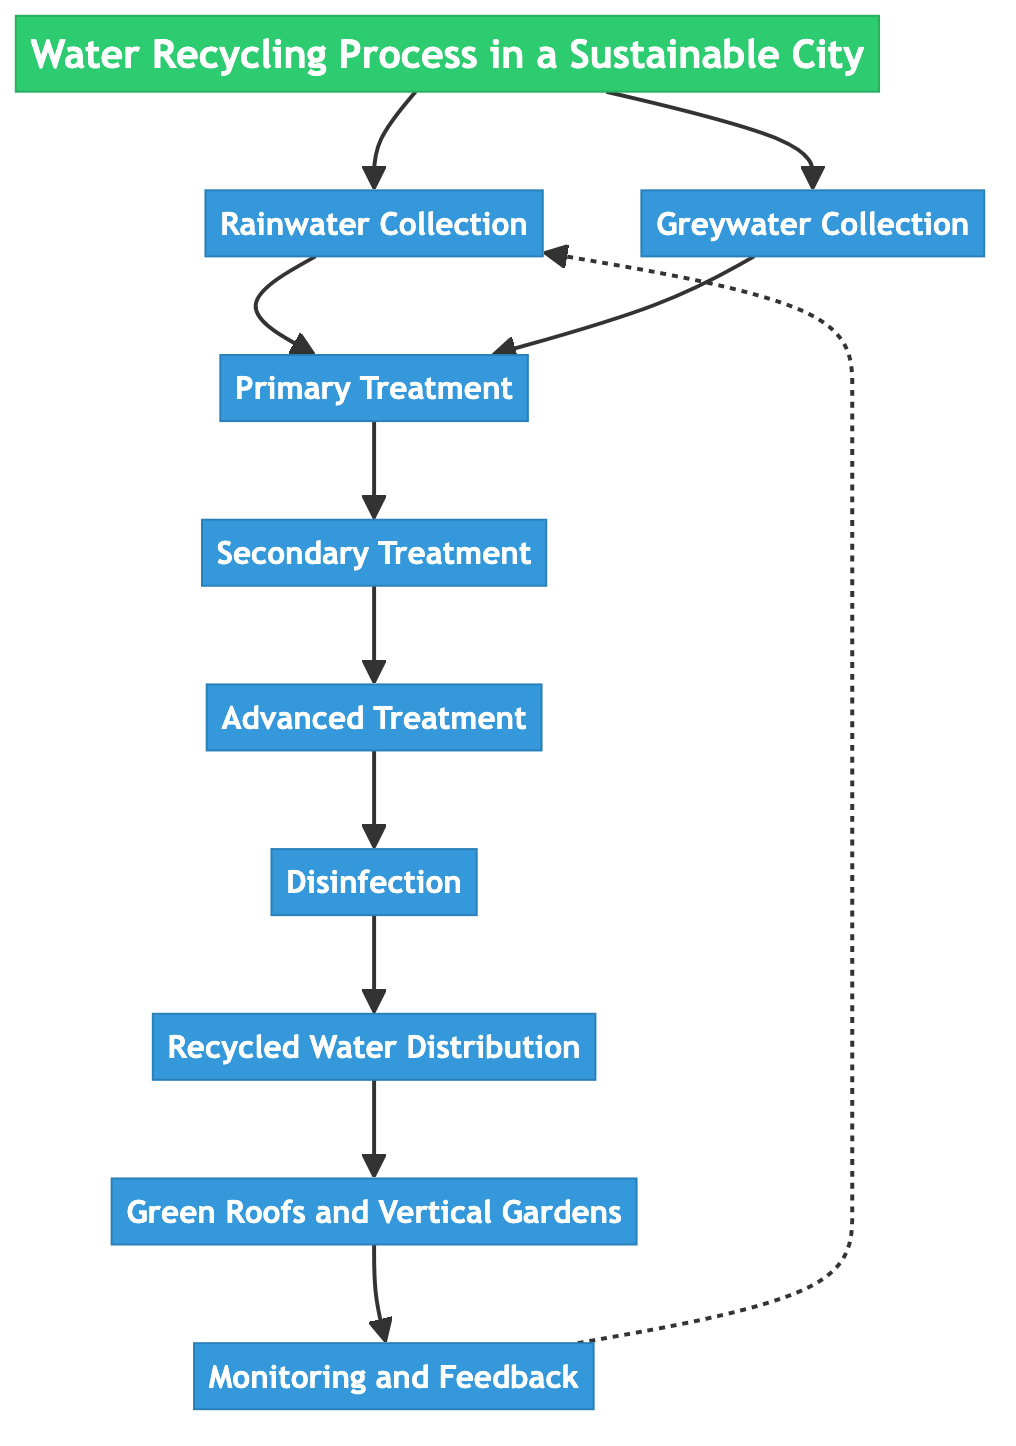What is the first step in the water recycling process? The diagram shows "Rainwater Collection" as the first step leading from the title. This step is indicated at the start of the flow chart.
Answer: Rainwater Collection How many steps are there in total? The flow chart contains a total of nine steps, including the two initial collection steps and the subsequent treatments, distribution, and feedback processes.
Answer: Nine Which process follows Primary Treatment? Following "Primary Treatment," the next step in the process is "Secondary Treatment," as indicated by the connecting arrow in the diagram.
Answer: Secondary Treatment What type of water is collected in Greywater Collection? "Greywater Collection" refers to the used water gathered from household sources like sinks, showers, and washing machines, as depicted in the diagram.
Answer: Used water What is the purpose of Disinfection in the process? The "Disinfection" step is crucial for applying methods like UV light or chlorination to eliminate pathogens from the water before distribution.
Answer: Eliminate pathogens What is the final step after Recycled Water Distribution? After "Recycled Water Distribution," the final step in the process is "Green Roofs and Vertical Gardens," where the treated water is utilized for irrigating green infrastructures.
Answer: Green Roofs and Vertical Gardens Which step utilizes smart sensors for optimization? The "Monitoring and Feedback" step is highlighted for implementing smart sensors and IoT technology for continuous monitoring and optimization of the entire water recycling system.
Answer: Monitoring and Feedback What connections exist between Green Roofs and Vertical Gardens and Rainwater Collection? There is a feedback loop connecting "Green Roofs and Vertical Gardens" back to "Rainwater Collection," represented by a dashed line, indicating the importance of collected rainwater in maintaining the green infrastructure.
Answer: Feedback loop What treatment method is used during Advanced Treatment? "Advanced Treatment" employs advanced filtration methods such as reverse osmosis to purify water, as specified in the flow chart.
Answer: Reverse osmosis 